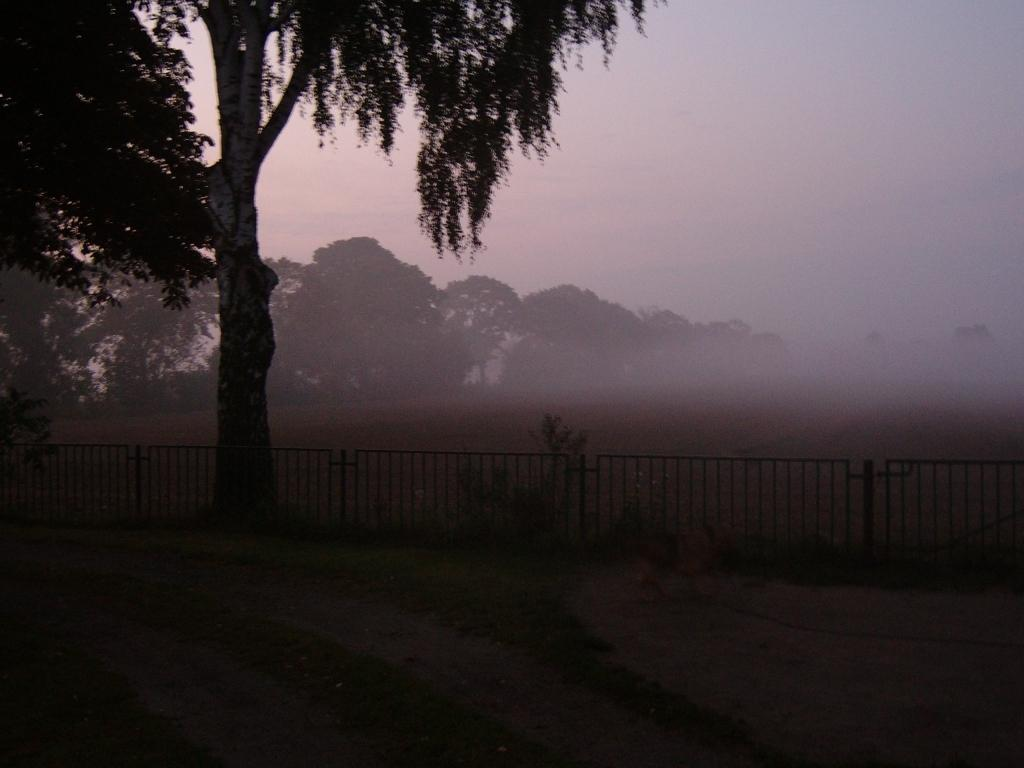What type of barrier can be seen in the image? There is a fence in the image. What type of vegetation is present in the image? There are trees in the image. What part of the natural environment is visible in the image? The ground is visible in the image. What is visible in the background of the image? The sky is visible in the background of the image. What can be observed in the sky? Clouds are present in the sky. Can you see any waste or litter on the seashore in the image? There is no seashore present in the image, so it is not possible to determine if there is any waste or litter. What type of creature can be seen interacting with the trees in the image? There are no creatures present in the image; only the fence, trees, ground, and sky are visible. 